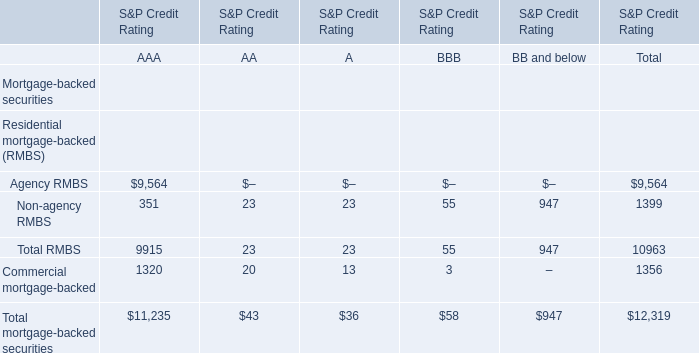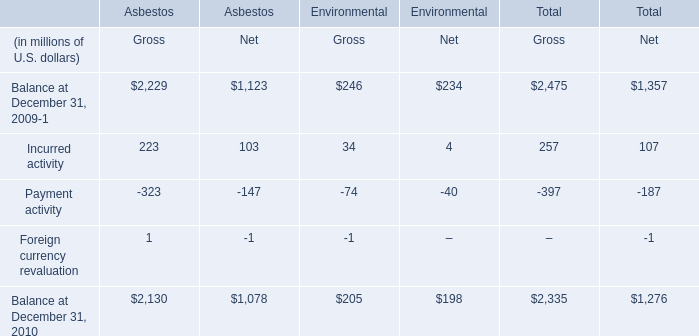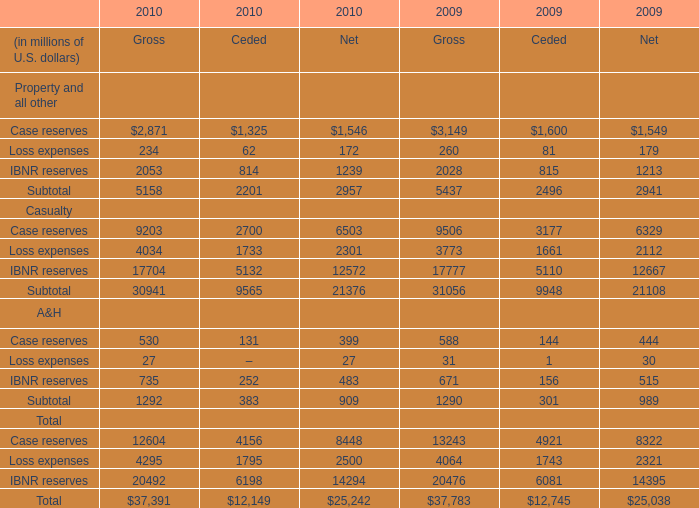what's the total amount of Balance at December 31, 2010 of Asbestos Net, and Loss expenses Casualty of 2010 Ceded ? 
Computations: (1078.0 + 1733.0)
Answer: 2811.0. 